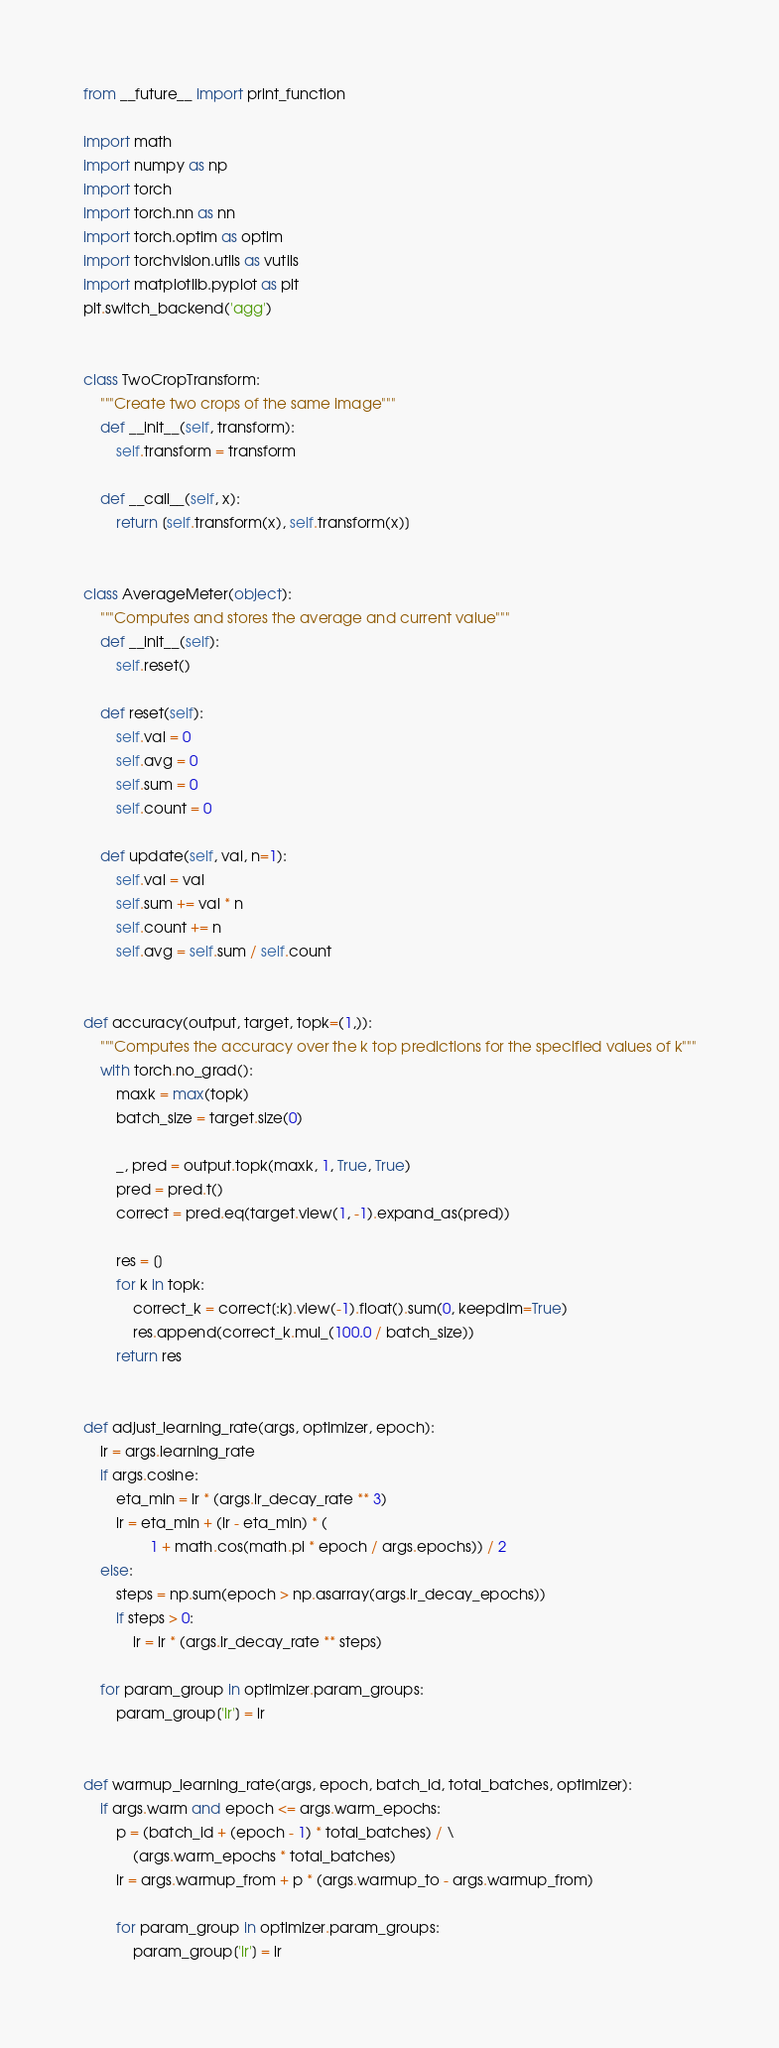Convert code to text. <code><loc_0><loc_0><loc_500><loc_500><_Python_>from __future__ import print_function

import math
import numpy as np
import torch
import torch.nn as nn
import torch.optim as optim
import torchvision.utils as vutils
import matplotlib.pyplot as plt
plt.switch_backend('agg') 


class TwoCropTransform:
    """Create two crops of the same image"""
    def __init__(self, transform):
        self.transform = transform

    def __call__(self, x):
        return [self.transform(x), self.transform(x)]


class AverageMeter(object):
    """Computes and stores the average and current value"""
    def __init__(self):
        self.reset()

    def reset(self):
        self.val = 0
        self.avg = 0
        self.sum = 0
        self.count = 0

    def update(self, val, n=1):
        self.val = val
        self.sum += val * n
        self.count += n
        self.avg = self.sum / self.count


def accuracy(output, target, topk=(1,)):
    """Computes the accuracy over the k top predictions for the specified values of k"""
    with torch.no_grad():
        maxk = max(topk)
        batch_size = target.size(0)

        _, pred = output.topk(maxk, 1, True, True)
        pred = pred.t()
        correct = pred.eq(target.view(1, -1).expand_as(pred))

        res = []
        for k in topk:
            correct_k = correct[:k].view(-1).float().sum(0, keepdim=True)
            res.append(correct_k.mul_(100.0 / batch_size))
        return res


def adjust_learning_rate(args, optimizer, epoch):
    lr = args.learning_rate
    if args.cosine:
        eta_min = lr * (args.lr_decay_rate ** 3)
        lr = eta_min + (lr - eta_min) * (
                1 + math.cos(math.pi * epoch / args.epochs)) / 2
    else:
        steps = np.sum(epoch > np.asarray(args.lr_decay_epochs))
        if steps > 0:
            lr = lr * (args.lr_decay_rate ** steps)

    for param_group in optimizer.param_groups:
        param_group['lr'] = lr


def warmup_learning_rate(args, epoch, batch_id, total_batches, optimizer):
    if args.warm and epoch <= args.warm_epochs:
        p = (batch_id + (epoch - 1) * total_batches) / \
            (args.warm_epochs * total_batches)
        lr = args.warmup_from + p * (args.warmup_to - args.warmup_from)

        for param_group in optimizer.param_groups:
            param_group['lr'] = lr

</code> 